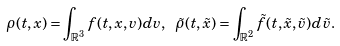<formula> <loc_0><loc_0><loc_500><loc_500>\rho ( t , x ) = \int _ { \mathbb { R } ^ { 3 } } f ( t , x , v ) d v , \ \tilde { \rho } ( t , \tilde { x } ) = \int _ { \mathbb { R } ^ { 2 } } \tilde { f } ( t , \tilde { x } , \tilde { v } ) d \tilde { v } .</formula> 